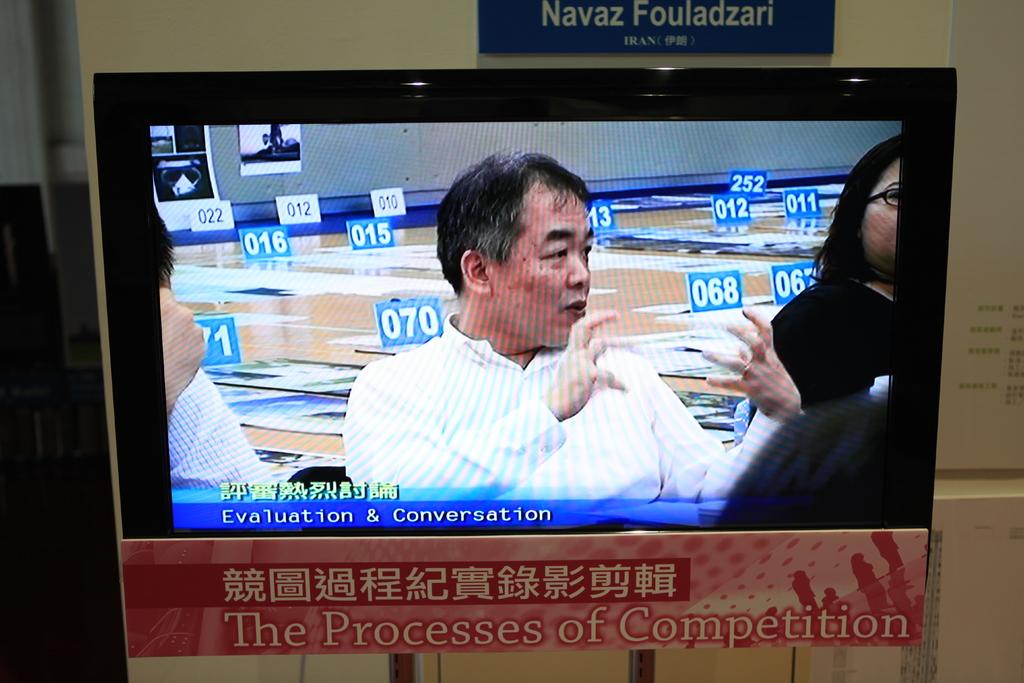What number is above the man's shoulder?
Provide a succinct answer. 070. What else is this man discussing besides evaluation?
Provide a short and direct response. Conversation. 